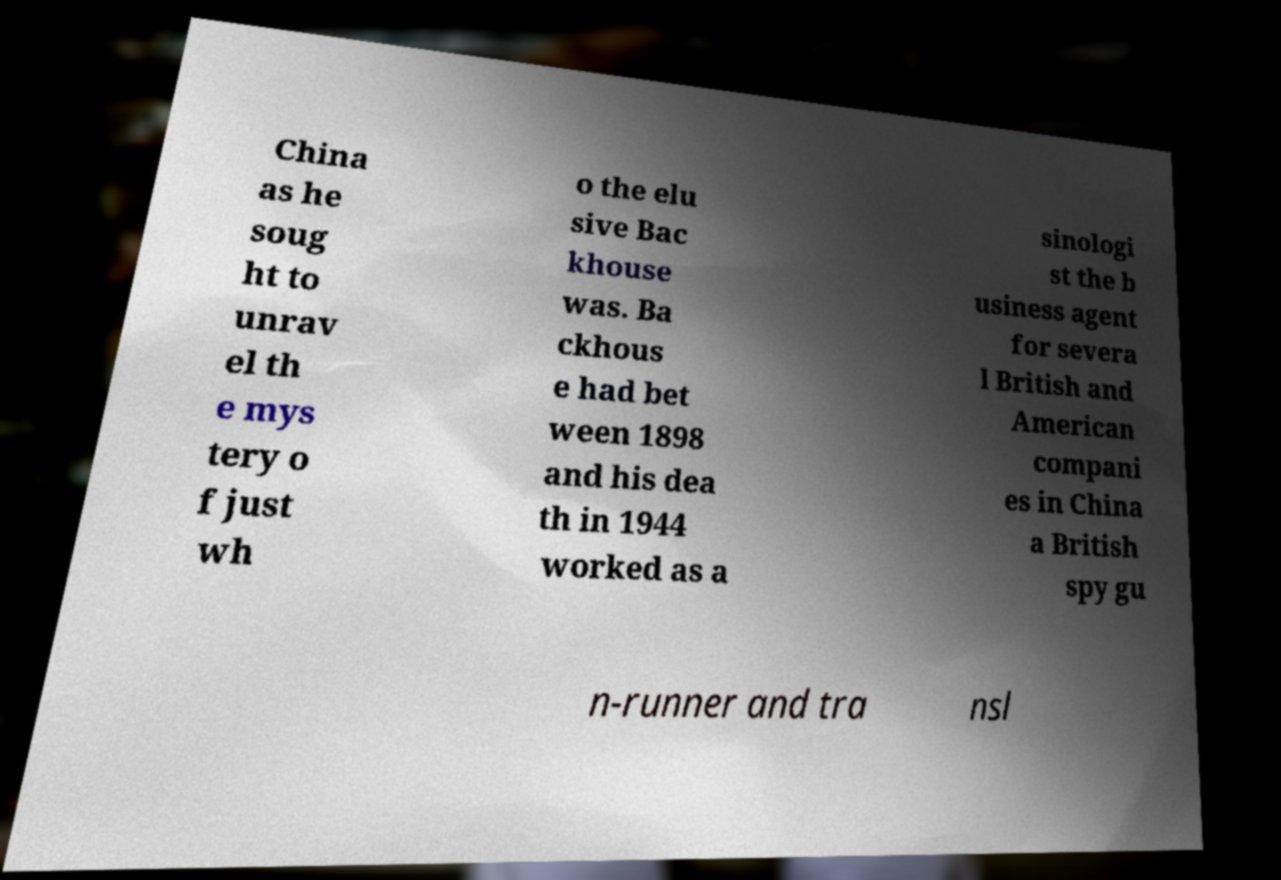What messages or text are displayed in this image? I need them in a readable, typed format. China as he soug ht to unrav el th e mys tery o f just wh o the elu sive Bac khouse was. Ba ckhous e had bet ween 1898 and his dea th in 1944 worked as a sinologi st the b usiness agent for severa l British and American compani es in China a British spy gu n-runner and tra nsl 